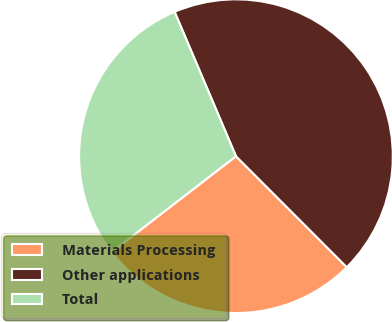Convert chart. <chart><loc_0><loc_0><loc_500><loc_500><pie_chart><fcel>Materials Processing<fcel>Other applications<fcel>Total<nl><fcel>27.03%<fcel>43.91%<fcel>29.06%<nl></chart> 